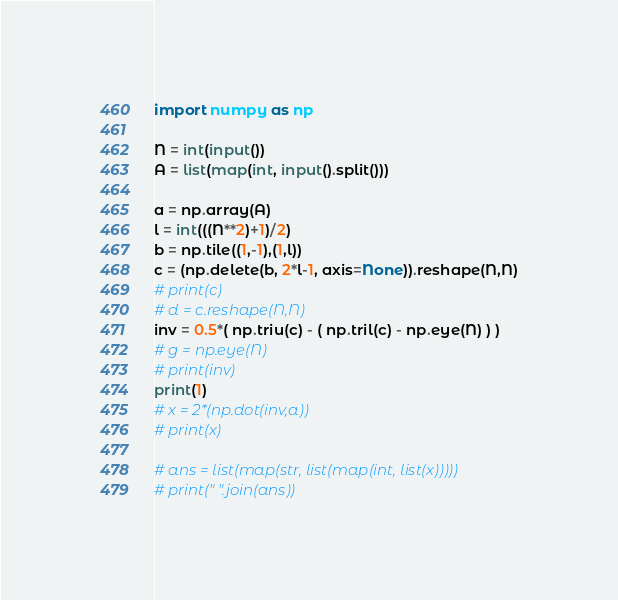<code> <loc_0><loc_0><loc_500><loc_500><_Python_>import numpy as np

N = int(input())
A = list(map(int, input().split()))

a = np.array(A)
l = int(((N**2)+1)/2)
b = np.tile((1,-1),(1,l))
c = (np.delete(b, 2*l-1, axis=None)).reshape(N,N)
# print(c)
# d = c.reshape(N,N)
inv = 0.5*( np.triu(c) - ( np.tril(c) - np.eye(N) ) )
# g = np.eye(N)
# print(inv)
print(1)
# x = 2*(np.dot(inv,a))
# print(x)

# ans = list(map(str, list(map(int, list(x)))))
# print(" ".join(ans))</code> 